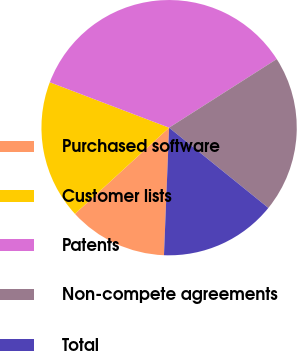Convert chart to OTSL. <chart><loc_0><loc_0><loc_500><loc_500><pie_chart><fcel>Purchased software<fcel>Customer lists<fcel>Patents<fcel>Non-compete agreements<fcel>Total<nl><fcel>12.56%<fcel>17.59%<fcel>35.18%<fcel>19.85%<fcel>14.82%<nl></chart> 